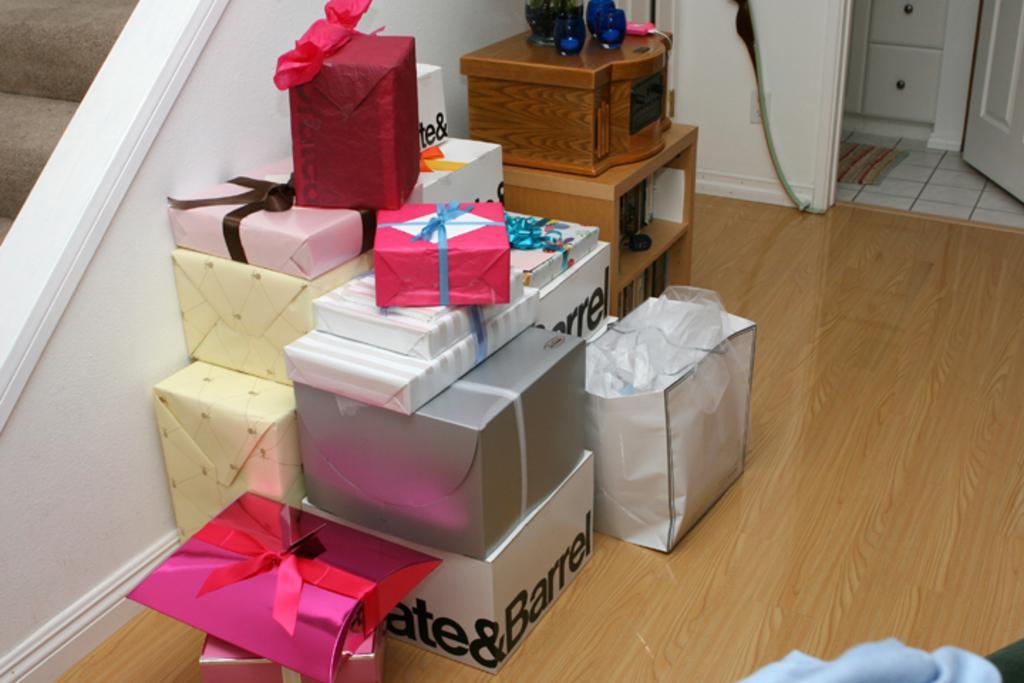In one or two sentences, can you explain what this image depicts? In this image we can see some gift boxes and a carry bag on the floor, also we can see a cupboard and a wooden box, on the wooden box, there are some glasses and also we can see the stairs, door and a mat. 